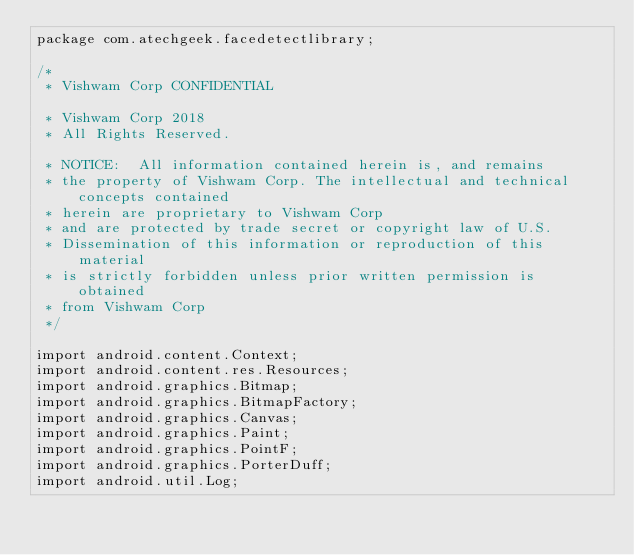<code> <loc_0><loc_0><loc_500><loc_500><_Java_>package com.atechgeek.facedetectlibrary;

/*
 * Vishwam Corp CONFIDENTIAL

 * Vishwam Corp 2018
 * All Rights Reserved.

 * NOTICE:  All information contained herein is, and remains
 * the property of Vishwam Corp. The intellectual and technical concepts contained
 * herein are proprietary to Vishwam Corp
 * and are protected by trade secret or copyright law of U.S.
 * Dissemination of this information or reproduction of this material
 * is strictly forbidden unless prior written permission is obtained
 * from Vishwam Corp
 */

import android.content.Context;
import android.content.res.Resources;
import android.graphics.Bitmap;
import android.graphics.BitmapFactory;
import android.graphics.Canvas;
import android.graphics.Paint;
import android.graphics.PointF;
import android.graphics.PorterDuff;
import android.util.Log;
</code> 